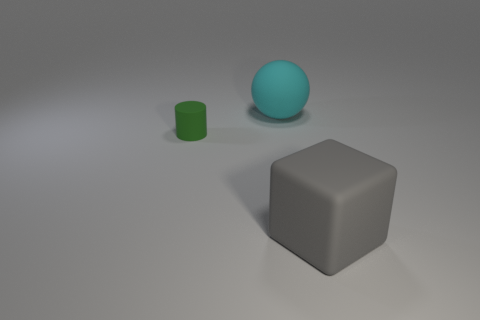Is there any other thing that is made of the same material as the big cyan object? Based on the visual properties of the objects depicted, it appears that all three items—a big cyan sphere, a smaller green cylinder, and a gray cube—could be made of a similar smooth, matte material, possibly a type of plastic or coated metal frequently used in computer-rendered images for simplistic objects. 